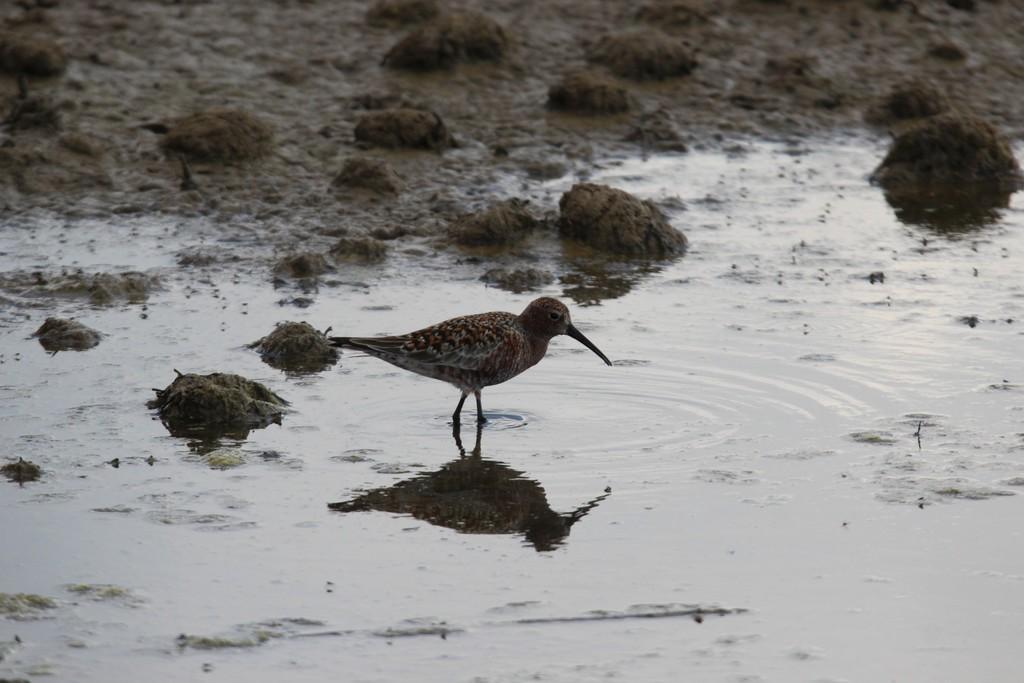Describe this image in one or two sentences. In the center of the image there is a bird. At the bottom we can see water. In the background there is mud. 